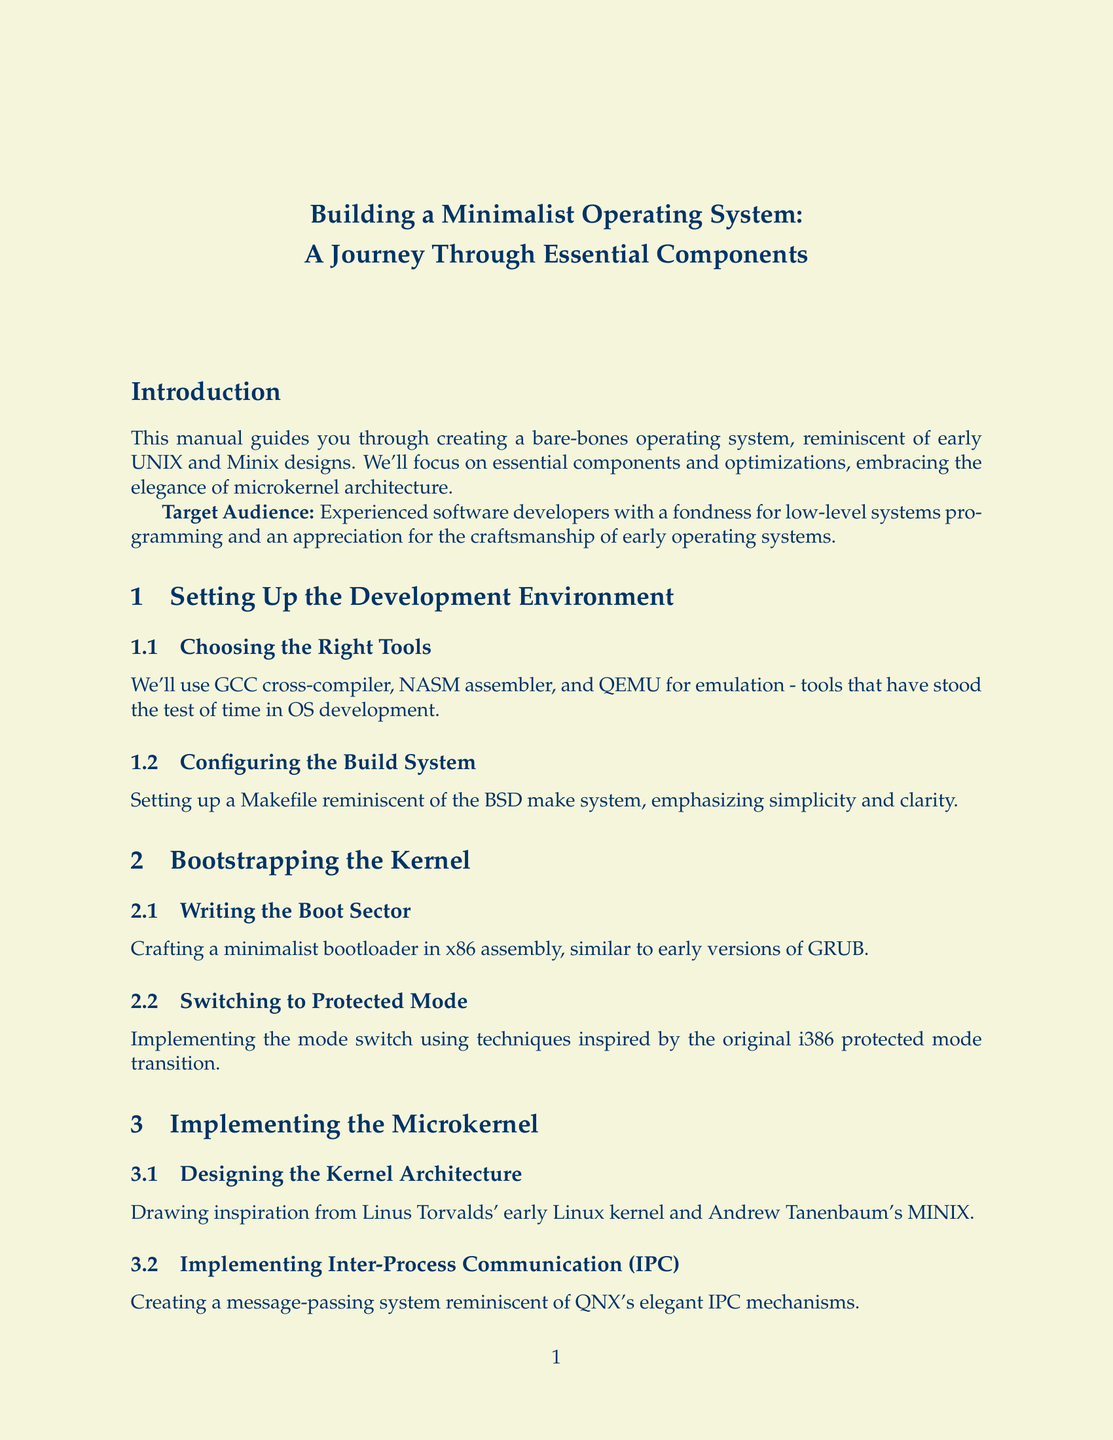What is the title of the manual? The title, as stated at the beginning of the document, summarizes the content and focus on building an operating system.
Answer: Building a Minimalist Operating System: A Journey Through Essential Components Who is the intended target audience for this manual? The target audience is specified in the introduction, highlighting the type of individuals who would benefit from the manual.
Answer: Experienced software developers What tool is used for emulation in the development environment? This tool is mentioned in the section on choosing the right tools, which emphasizes its importance in OS development.
Answer: QEMU Which chapter discusses memory management? This information is found in Chapter 3, which focuses specifically on the microkernel and its components.
Answer: Chapter 3: Implementing the Microkernel What basic file operation is included in Chapter 5? This operation is listed in the section on implementing basic file operations, which focuses on foundational tasks related to file systems.
Answer: Delete What type of driver is implemented in Chapter 4? The chapter discusses building essential drivers, with a focus on input and display handling from early computer systems.
Answer: Keyboard Driver Which chapter outlines future expansion possibilities? The chapter that addresses future directions provides insight into potential developments and enhancements for the operating system.
Answer: Chapter 8: Future Directions and Expansion What memory management improvement is suggested in Chapter 7? This improvement is noted in the optimizations and refinements section, emphasizing a specific strategy to enhance the OS’s performance.
Answer: Buddy allocator system What command interpreter is mentioned in Chapter 6? The document references this interpreter while discussing how command parsing is designed in the context of simplicity and usability.
Answer: Thompson shell 